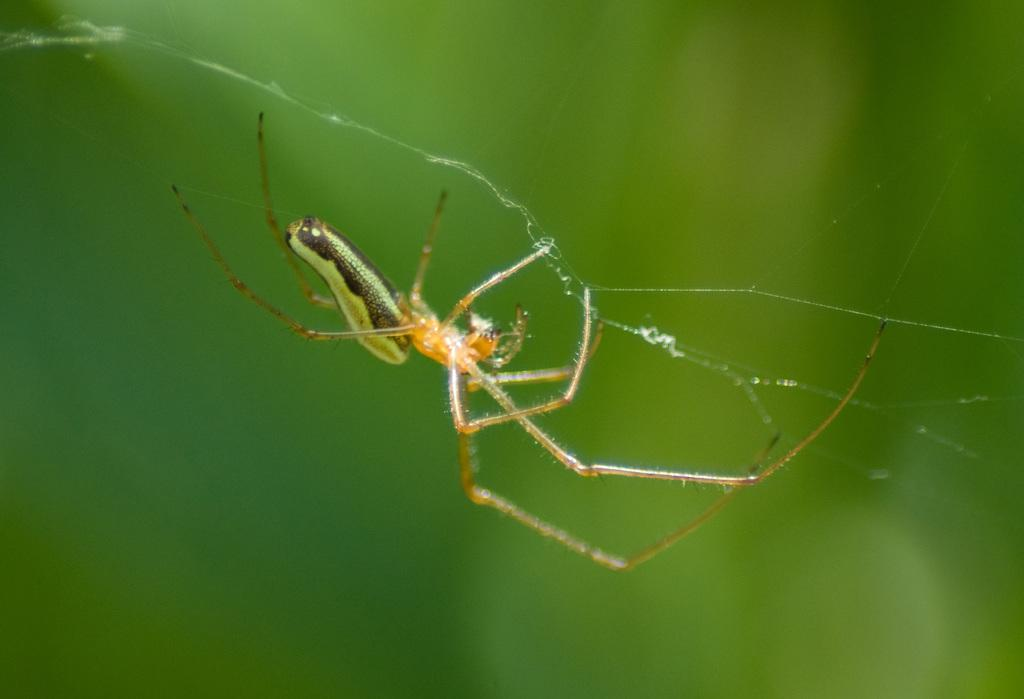What is located in the foreground of the image? There is a spider in the foreground of the image. What is associated with the spider in the foreground of the image? There is a web associated with the spider in the foreground of the image. Can you describe the background of the image? The background of the image is blurry. How many sisters are visible in the image? There are no sisters present in the image. Is the spider in the image being held in a jail cell? There is no jail cell present in the image, and the spider is not being held captive. Is the spider in the image asking for help? There is no indication in the image that the spider is asking for help. 